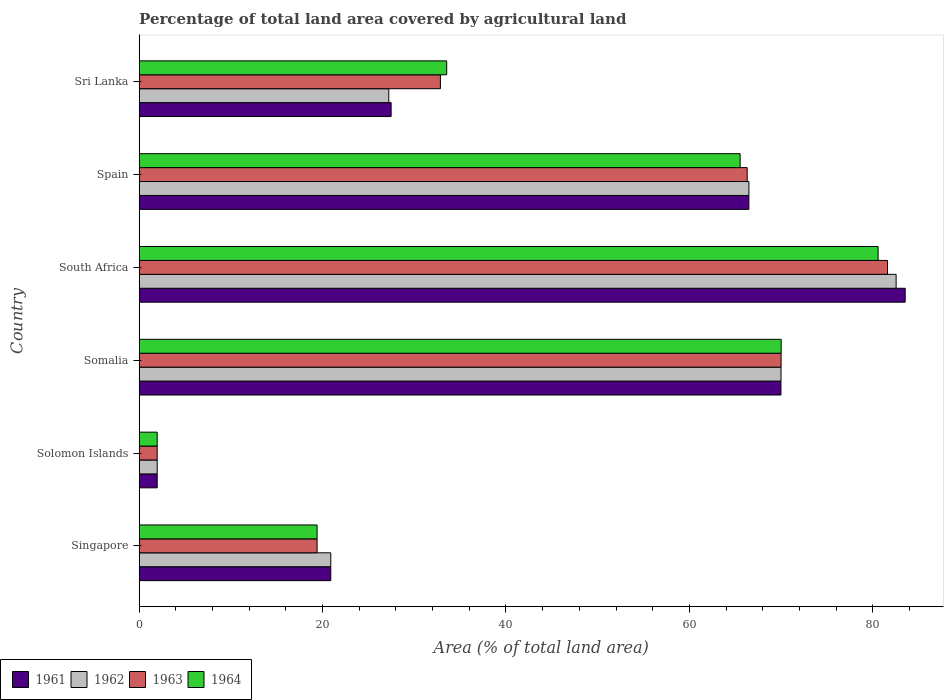How many bars are there on the 5th tick from the top?
Ensure brevity in your answer.  4. How many bars are there on the 2nd tick from the bottom?
Provide a short and direct response. 4. What is the label of the 3rd group of bars from the top?
Your response must be concise. South Africa. What is the percentage of agricultural land in 1962 in Singapore?
Give a very brief answer. 20.9. Across all countries, what is the maximum percentage of agricultural land in 1963?
Ensure brevity in your answer.  81.61. Across all countries, what is the minimum percentage of agricultural land in 1961?
Provide a succinct answer. 1.96. In which country was the percentage of agricultural land in 1963 maximum?
Provide a succinct answer. South Africa. In which country was the percentage of agricultural land in 1962 minimum?
Provide a short and direct response. Solomon Islands. What is the total percentage of agricultural land in 1964 in the graph?
Your answer should be very brief. 271.03. What is the difference between the percentage of agricultural land in 1963 in Solomon Islands and that in Spain?
Ensure brevity in your answer.  -64.34. What is the difference between the percentage of agricultural land in 1961 in Solomon Islands and the percentage of agricultural land in 1963 in Singapore?
Offer a terse response. -17.44. What is the average percentage of agricultural land in 1961 per country?
Keep it short and to the point. 45.06. What is the difference between the percentage of agricultural land in 1963 and percentage of agricultural land in 1964 in Somalia?
Give a very brief answer. -0.01. In how many countries, is the percentage of agricultural land in 1964 greater than 52 %?
Your answer should be very brief. 3. What is the ratio of the percentage of agricultural land in 1963 in Solomon Islands to that in Somalia?
Your response must be concise. 0.03. Is the percentage of agricultural land in 1962 in Somalia less than that in South Africa?
Make the answer very short. Yes. Is the difference between the percentage of agricultural land in 1963 in Singapore and Somalia greater than the difference between the percentage of agricultural land in 1964 in Singapore and Somalia?
Offer a terse response. Yes. What is the difference between the highest and the second highest percentage of agricultural land in 1964?
Your answer should be very brief. 10.57. What is the difference between the highest and the lowest percentage of agricultural land in 1962?
Ensure brevity in your answer.  80.58. Is the sum of the percentage of agricultural land in 1962 in Singapore and South Africa greater than the maximum percentage of agricultural land in 1961 across all countries?
Your answer should be very brief. Yes. What does the 1st bar from the top in Somalia represents?
Provide a short and direct response. 1964. What does the 3rd bar from the bottom in Singapore represents?
Make the answer very short. 1963. How many bars are there?
Provide a succinct answer. 24. Are all the bars in the graph horizontal?
Offer a terse response. Yes. How many countries are there in the graph?
Offer a terse response. 6. Are the values on the major ticks of X-axis written in scientific E-notation?
Your answer should be compact. No. How many legend labels are there?
Offer a very short reply. 4. What is the title of the graph?
Ensure brevity in your answer.  Percentage of total land area covered by agricultural land. What is the label or title of the X-axis?
Offer a very short reply. Area (% of total land area). What is the label or title of the Y-axis?
Keep it short and to the point. Country. What is the Area (% of total land area) in 1961 in Singapore?
Make the answer very short. 20.9. What is the Area (% of total land area) of 1962 in Singapore?
Your response must be concise. 20.9. What is the Area (% of total land area) in 1963 in Singapore?
Provide a short and direct response. 19.4. What is the Area (% of total land area) of 1964 in Singapore?
Offer a very short reply. 19.4. What is the Area (% of total land area) in 1961 in Solomon Islands?
Offer a very short reply. 1.96. What is the Area (% of total land area) of 1962 in Solomon Islands?
Your answer should be very brief. 1.96. What is the Area (% of total land area) of 1963 in Solomon Islands?
Offer a terse response. 1.96. What is the Area (% of total land area) of 1964 in Solomon Islands?
Offer a terse response. 1.96. What is the Area (% of total land area) in 1961 in Somalia?
Make the answer very short. 69.99. What is the Area (% of total land area) in 1962 in Somalia?
Keep it short and to the point. 69.99. What is the Area (% of total land area) in 1963 in Somalia?
Offer a terse response. 70. What is the Area (% of total land area) of 1964 in Somalia?
Your answer should be compact. 70.01. What is the Area (% of total land area) of 1961 in South Africa?
Provide a succinct answer. 83.53. What is the Area (% of total land area) of 1962 in South Africa?
Provide a succinct answer. 82.55. What is the Area (% of total land area) in 1963 in South Africa?
Make the answer very short. 81.61. What is the Area (% of total land area) in 1964 in South Africa?
Your response must be concise. 80.58. What is the Area (% of total land area) of 1961 in Spain?
Provide a succinct answer. 66.49. What is the Area (% of total land area) in 1962 in Spain?
Offer a terse response. 66.49. What is the Area (% of total land area) of 1963 in Spain?
Provide a short and direct response. 66.3. What is the Area (% of total land area) of 1964 in Spain?
Your answer should be compact. 65.53. What is the Area (% of total land area) in 1961 in Sri Lanka?
Offer a terse response. 27.48. What is the Area (% of total land area) in 1962 in Sri Lanka?
Offer a terse response. 27.22. What is the Area (% of total land area) of 1963 in Sri Lanka?
Your answer should be very brief. 32.85. What is the Area (% of total land area) in 1964 in Sri Lanka?
Offer a very short reply. 33.54. Across all countries, what is the maximum Area (% of total land area) of 1961?
Your response must be concise. 83.53. Across all countries, what is the maximum Area (% of total land area) of 1962?
Offer a very short reply. 82.55. Across all countries, what is the maximum Area (% of total land area) of 1963?
Keep it short and to the point. 81.61. Across all countries, what is the maximum Area (% of total land area) in 1964?
Provide a succinct answer. 80.58. Across all countries, what is the minimum Area (% of total land area) in 1961?
Offer a terse response. 1.96. Across all countries, what is the minimum Area (% of total land area) in 1962?
Your response must be concise. 1.96. Across all countries, what is the minimum Area (% of total land area) in 1963?
Give a very brief answer. 1.96. Across all countries, what is the minimum Area (% of total land area) of 1964?
Provide a succinct answer. 1.96. What is the total Area (% of total land area) in 1961 in the graph?
Provide a succinct answer. 270.35. What is the total Area (% of total land area) of 1962 in the graph?
Provide a short and direct response. 269.11. What is the total Area (% of total land area) of 1963 in the graph?
Your answer should be very brief. 272.13. What is the total Area (% of total land area) in 1964 in the graph?
Your response must be concise. 271.03. What is the difference between the Area (% of total land area) in 1961 in Singapore and that in Solomon Islands?
Your response must be concise. 18.93. What is the difference between the Area (% of total land area) in 1962 in Singapore and that in Solomon Islands?
Your response must be concise. 18.93. What is the difference between the Area (% of total land area) in 1963 in Singapore and that in Solomon Islands?
Offer a terse response. 17.44. What is the difference between the Area (% of total land area) in 1964 in Singapore and that in Solomon Islands?
Keep it short and to the point. 17.44. What is the difference between the Area (% of total land area) in 1961 in Singapore and that in Somalia?
Your answer should be very brief. -49.09. What is the difference between the Area (% of total land area) of 1962 in Singapore and that in Somalia?
Your answer should be very brief. -49.1. What is the difference between the Area (% of total land area) of 1963 in Singapore and that in Somalia?
Ensure brevity in your answer.  -50.6. What is the difference between the Area (% of total land area) in 1964 in Singapore and that in Somalia?
Your answer should be compact. -50.61. What is the difference between the Area (% of total land area) of 1961 in Singapore and that in South Africa?
Provide a succinct answer. -62.64. What is the difference between the Area (% of total land area) of 1962 in Singapore and that in South Africa?
Make the answer very short. -61.65. What is the difference between the Area (% of total land area) in 1963 in Singapore and that in South Africa?
Make the answer very short. -62.2. What is the difference between the Area (% of total land area) in 1964 in Singapore and that in South Africa?
Your answer should be very brief. -61.18. What is the difference between the Area (% of total land area) in 1961 in Singapore and that in Spain?
Make the answer very short. -45.59. What is the difference between the Area (% of total land area) in 1962 in Singapore and that in Spain?
Your answer should be very brief. -45.6. What is the difference between the Area (% of total land area) in 1963 in Singapore and that in Spain?
Give a very brief answer. -46.9. What is the difference between the Area (% of total land area) of 1964 in Singapore and that in Spain?
Your answer should be compact. -46.13. What is the difference between the Area (% of total land area) of 1961 in Singapore and that in Sri Lanka?
Your response must be concise. -6.58. What is the difference between the Area (% of total land area) in 1962 in Singapore and that in Sri Lanka?
Provide a short and direct response. -6.33. What is the difference between the Area (% of total land area) in 1963 in Singapore and that in Sri Lanka?
Keep it short and to the point. -13.45. What is the difference between the Area (% of total land area) of 1964 in Singapore and that in Sri Lanka?
Your answer should be compact. -14.13. What is the difference between the Area (% of total land area) in 1961 in Solomon Islands and that in Somalia?
Provide a succinct answer. -68.02. What is the difference between the Area (% of total land area) in 1962 in Solomon Islands and that in Somalia?
Offer a terse response. -68.03. What is the difference between the Area (% of total land area) in 1963 in Solomon Islands and that in Somalia?
Your response must be concise. -68.04. What is the difference between the Area (% of total land area) of 1964 in Solomon Islands and that in Somalia?
Provide a succinct answer. -68.04. What is the difference between the Area (% of total land area) of 1961 in Solomon Islands and that in South Africa?
Ensure brevity in your answer.  -81.57. What is the difference between the Area (% of total land area) of 1962 in Solomon Islands and that in South Africa?
Provide a succinct answer. -80.58. What is the difference between the Area (% of total land area) in 1963 in Solomon Islands and that in South Africa?
Provide a succinct answer. -79.64. What is the difference between the Area (% of total land area) in 1964 in Solomon Islands and that in South Africa?
Your response must be concise. -78.61. What is the difference between the Area (% of total land area) in 1961 in Solomon Islands and that in Spain?
Provide a succinct answer. -64.52. What is the difference between the Area (% of total land area) in 1962 in Solomon Islands and that in Spain?
Ensure brevity in your answer.  -64.53. What is the difference between the Area (% of total land area) in 1963 in Solomon Islands and that in Spain?
Offer a very short reply. -64.34. What is the difference between the Area (% of total land area) in 1964 in Solomon Islands and that in Spain?
Provide a short and direct response. -63.57. What is the difference between the Area (% of total land area) in 1961 in Solomon Islands and that in Sri Lanka?
Your answer should be compact. -25.51. What is the difference between the Area (% of total land area) in 1962 in Solomon Islands and that in Sri Lanka?
Your response must be concise. -25.26. What is the difference between the Area (% of total land area) in 1963 in Solomon Islands and that in Sri Lanka?
Your answer should be very brief. -30.88. What is the difference between the Area (% of total land area) of 1964 in Solomon Islands and that in Sri Lanka?
Provide a short and direct response. -31.57. What is the difference between the Area (% of total land area) in 1961 in Somalia and that in South Africa?
Make the answer very short. -13.55. What is the difference between the Area (% of total land area) in 1962 in Somalia and that in South Africa?
Give a very brief answer. -12.55. What is the difference between the Area (% of total land area) of 1963 in Somalia and that in South Africa?
Your answer should be very brief. -11.6. What is the difference between the Area (% of total land area) of 1964 in Somalia and that in South Africa?
Provide a succinct answer. -10.57. What is the difference between the Area (% of total land area) in 1961 in Somalia and that in Spain?
Your response must be concise. 3.5. What is the difference between the Area (% of total land area) in 1962 in Somalia and that in Spain?
Provide a short and direct response. 3.5. What is the difference between the Area (% of total land area) of 1963 in Somalia and that in Spain?
Your answer should be very brief. 3.7. What is the difference between the Area (% of total land area) of 1964 in Somalia and that in Spain?
Your answer should be very brief. 4.47. What is the difference between the Area (% of total land area) of 1961 in Somalia and that in Sri Lanka?
Ensure brevity in your answer.  42.51. What is the difference between the Area (% of total land area) of 1962 in Somalia and that in Sri Lanka?
Your response must be concise. 42.77. What is the difference between the Area (% of total land area) in 1963 in Somalia and that in Sri Lanka?
Your response must be concise. 37.15. What is the difference between the Area (% of total land area) in 1964 in Somalia and that in Sri Lanka?
Ensure brevity in your answer.  36.47. What is the difference between the Area (% of total land area) of 1961 in South Africa and that in Spain?
Offer a terse response. 17.05. What is the difference between the Area (% of total land area) of 1962 in South Africa and that in Spain?
Provide a succinct answer. 16.05. What is the difference between the Area (% of total land area) in 1963 in South Africa and that in Spain?
Offer a very short reply. 15.3. What is the difference between the Area (% of total land area) of 1964 in South Africa and that in Spain?
Your response must be concise. 15.04. What is the difference between the Area (% of total land area) of 1961 in South Africa and that in Sri Lanka?
Provide a succinct answer. 56.06. What is the difference between the Area (% of total land area) of 1962 in South Africa and that in Sri Lanka?
Provide a short and direct response. 55.32. What is the difference between the Area (% of total land area) in 1963 in South Africa and that in Sri Lanka?
Offer a very short reply. 48.76. What is the difference between the Area (% of total land area) in 1964 in South Africa and that in Sri Lanka?
Ensure brevity in your answer.  47.04. What is the difference between the Area (% of total land area) in 1961 in Spain and that in Sri Lanka?
Provide a succinct answer. 39.01. What is the difference between the Area (% of total land area) in 1962 in Spain and that in Sri Lanka?
Make the answer very short. 39.27. What is the difference between the Area (% of total land area) of 1963 in Spain and that in Sri Lanka?
Your answer should be compact. 33.45. What is the difference between the Area (% of total land area) in 1964 in Spain and that in Sri Lanka?
Offer a terse response. 32. What is the difference between the Area (% of total land area) of 1961 in Singapore and the Area (% of total land area) of 1962 in Solomon Islands?
Ensure brevity in your answer.  18.93. What is the difference between the Area (% of total land area) in 1961 in Singapore and the Area (% of total land area) in 1963 in Solomon Islands?
Ensure brevity in your answer.  18.93. What is the difference between the Area (% of total land area) of 1961 in Singapore and the Area (% of total land area) of 1964 in Solomon Islands?
Your answer should be very brief. 18.93. What is the difference between the Area (% of total land area) of 1962 in Singapore and the Area (% of total land area) of 1963 in Solomon Islands?
Your answer should be compact. 18.93. What is the difference between the Area (% of total land area) of 1962 in Singapore and the Area (% of total land area) of 1964 in Solomon Islands?
Your response must be concise. 18.93. What is the difference between the Area (% of total land area) of 1963 in Singapore and the Area (% of total land area) of 1964 in Solomon Islands?
Provide a succinct answer. 17.44. What is the difference between the Area (% of total land area) in 1961 in Singapore and the Area (% of total land area) in 1962 in Somalia?
Your response must be concise. -49.1. What is the difference between the Area (% of total land area) in 1961 in Singapore and the Area (% of total land area) in 1963 in Somalia?
Give a very brief answer. -49.11. What is the difference between the Area (% of total land area) of 1961 in Singapore and the Area (% of total land area) of 1964 in Somalia?
Your answer should be very brief. -49.11. What is the difference between the Area (% of total land area) in 1962 in Singapore and the Area (% of total land area) in 1963 in Somalia?
Offer a very short reply. -49.11. What is the difference between the Area (% of total land area) of 1962 in Singapore and the Area (% of total land area) of 1964 in Somalia?
Your answer should be very brief. -49.11. What is the difference between the Area (% of total land area) of 1963 in Singapore and the Area (% of total land area) of 1964 in Somalia?
Your answer should be compact. -50.61. What is the difference between the Area (% of total land area) in 1961 in Singapore and the Area (% of total land area) in 1962 in South Africa?
Keep it short and to the point. -61.65. What is the difference between the Area (% of total land area) in 1961 in Singapore and the Area (% of total land area) in 1963 in South Africa?
Provide a succinct answer. -60.71. What is the difference between the Area (% of total land area) of 1961 in Singapore and the Area (% of total land area) of 1964 in South Africa?
Your answer should be compact. -59.68. What is the difference between the Area (% of total land area) of 1962 in Singapore and the Area (% of total land area) of 1963 in South Africa?
Your answer should be very brief. -60.71. What is the difference between the Area (% of total land area) in 1962 in Singapore and the Area (% of total land area) in 1964 in South Africa?
Offer a very short reply. -59.68. What is the difference between the Area (% of total land area) of 1963 in Singapore and the Area (% of total land area) of 1964 in South Africa?
Provide a short and direct response. -61.18. What is the difference between the Area (% of total land area) of 1961 in Singapore and the Area (% of total land area) of 1962 in Spain?
Ensure brevity in your answer.  -45.6. What is the difference between the Area (% of total land area) of 1961 in Singapore and the Area (% of total land area) of 1963 in Spain?
Offer a very short reply. -45.41. What is the difference between the Area (% of total land area) of 1961 in Singapore and the Area (% of total land area) of 1964 in Spain?
Offer a very short reply. -44.64. What is the difference between the Area (% of total land area) of 1962 in Singapore and the Area (% of total land area) of 1963 in Spain?
Your response must be concise. -45.41. What is the difference between the Area (% of total land area) of 1962 in Singapore and the Area (% of total land area) of 1964 in Spain?
Offer a terse response. -44.64. What is the difference between the Area (% of total land area) of 1963 in Singapore and the Area (% of total land area) of 1964 in Spain?
Offer a terse response. -46.13. What is the difference between the Area (% of total land area) of 1961 in Singapore and the Area (% of total land area) of 1962 in Sri Lanka?
Keep it short and to the point. -6.33. What is the difference between the Area (% of total land area) in 1961 in Singapore and the Area (% of total land area) in 1963 in Sri Lanka?
Offer a very short reply. -11.95. What is the difference between the Area (% of total land area) in 1961 in Singapore and the Area (% of total land area) in 1964 in Sri Lanka?
Ensure brevity in your answer.  -12.64. What is the difference between the Area (% of total land area) in 1962 in Singapore and the Area (% of total land area) in 1963 in Sri Lanka?
Make the answer very short. -11.95. What is the difference between the Area (% of total land area) of 1962 in Singapore and the Area (% of total land area) of 1964 in Sri Lanka?
Provide a succinct answer. -12.64. What is the difference between the Area (% of total land area) in 1963 in Singapore and the Area (% of total land area) in 1964 in Sri Lanka?
Offer a very short reply. -14.13. What is the difference between the Area (% of total land area) of 1961 in Solomon Islands and the Area (% of total land area) of 1962 in Somalia?
Make the answer very short. -68.03. What is the difference between the Area (% of total land area) in 1961 in Solomon Islands and the Area (% of total land area) in 1963 in Somalia?
Offer a very short reply. -68.04. What is the difference between the Area (% of total land area) of 1961 in Solomon Islands and the Area (% of total land area) of 1964 in Somalia?
Ensure brevity in your answer.  -68.04. What is the difference between the Area (% of total land area) in 1962 in Solomon Islands and the Area (% of total land area) in 1963 in Somalia?
Your answer should be very brief. -68.04. What is the difference between the Area (% of total land area) in 1962 in Solomon Islands and the Area (% of total land area) in 1964 in Somalia?
Provide a short and direct response. -68.04. What is the difference between the Area (% of total land area) in 1963 in Solomon Islands and the Area (% of total land area) in 1964 in Somalia?
Offer a terse response. -68.04. What is the difference between the Area (% of total land area) of 1961 in Solomon Islands and the Area (% of total land area) of 1962 in South Africa?
Your answer should be compact. -80.58. What is the difference between the Area (% of total land area) in 1961 in Solomon Islands and the Area (% of total land area) in 1963 in South Africa?
Make the answer very short. -79.64. What is the difference between the Area (% of total land area) in 1961 in Solomon Islands and the Area (% of total land area) in 1964 in South Africa?
Your answer should be very brief. -78.61. What is the difference between the Area (% of total land area) of 1962 in Solomon Islands and the Area (% of total land area) of 1963 in South Africa?
Make the answer very short. -79.64. What is the difference between the Area (% of total land area) in 1962 in Solomon Islands and the Area (% of total land area) in 1964 in South Africa?
Keep it short and to the point. -78.61. What is the difference between the Area (% of total land area) of 1963 in Solomon Islands and the Area (% of total land area) of 1964 in South Africa?
Your answer should be compact. -78.61. What is the difference between the Area (% of total land area) of 1961 in Solomon Islands and the Area (% of total land area) of 1962 in Spain?
Provide a succinct answer. -64.53. What is the difference between the Area (% of total land area) in 1961 in Solomon Islands and the Area (% of total land area) in 1963 in Spain?
Provide a succinct answer. -64.34. What is the difference between the Area (% of total land area) in 1961 in Solomon Islands and the Area (% of total land area) in 1964 in Spain?
Ensure brevity in your answer.  -63.57. What is the difference between the Area (% of total land area) of 1962 in Solomon Islands and the Area (% of total land area) of 1963 in Spain?
Your answer should be compact. -64.34. What is the difference between the Area (% of total land area) of 1962 in Solomon Islands and the Area (% of total land area) of 1964 in Spain?
Your response must be concise. -63.57. What is the difference between the Area (% of total land area) of 1963 in Solomon Islands and the Area (% of total land area) of 1964 in Spain?
Ensure brevity in your answer.  -63.57. What is the difference between the Area (% of total land area) in 1961 in Solomon Islands and the Area (% of total land area) in 1962 in Sri Lanka?
Provide a succinct answer. -25.26. What is the difference between the Area (% of total land area) of 1961 in Solomon Islands and the Area (% of total land area) of 1963 in Sri Lanka?
Provide a short and direct response. -30.88. What is the difference between the Area (% of total land area) in 1961 in Solomon Islands and the Area (% of total land area) in 1964 in Sri Lanka?
Keep it short and to the point. -31.57. What is the difference between the Area (% of total land area) in 1962 in Solomon Islands and the Area (% of total land area) in 1963 in Sri Lanka?
Provide a short and direct response. -30.88. What is the difference between the Area (% of total land area) of 1962 in Solomon Islands and the Area (% of total land area) of 1964 in Sri Lanka?
Ensure brevity in your answer.  -31.57. What is the difference between the Area (% of total land area) in 1963 in Solomon Islands and the Area (% of total land area) in 1964 in Sri Lanka?
Your answer should be very brief. -31.57. What is the difference between the Area (% of total land area) of 1961 in Somalia and the Area (% of total land area) of 1962 in South Africa?
Give a very brief answer. -12.56. What is the difference between the Area (% of total land area) in 1961 in Somalia and the Area (% of total land area) in 1963 in South Africa?
Your response must be concise. -11.62. What is the difference between the Area (% of total land area) of 1961 in Somalia and the Area (% of total land area) of 1964 in South Africa?
Make the answer very short. -10.59. What is the difference between the Area (% of total land area) of 1962 in Somalia and the Area (% of total land area) of 1963 in South Africa?
Provide a short and direct response. -11.61. What is the difference between the Area (% of total land area) in 1962 in Somalia and the Area (% of total land area) in 1964 in South Africa?
Offer a very short reply. -10.59. What is the difference between the Area (% of total land area) of 1963 in Somalia and the Area (% of total land area) of 1964 in South Africa?
Make the answer very short. -10.58. What is the difference between the Area (% of total land area) in 1961 in Somalia and the Area (% of total land area) in 1962 in Spain?
Offer a terse response. 3.49. What is the difference between the Area (% of total land area) of 1961 in Somalia and the Area (% of total land area) of 1963 in Spain?
Your answer should be very brief. 3.68. What is the difference between the Area (% of total land area) of 1961 in Somalia and the Area (% of total land area) of 1964 in Spain?
Your answer should be very brief. 4.45. What is the difference between the Area (% of total land area) in 1962 in Somalia and the Area (% of total land area) in 1963 in Spain?
Provide a succinct answer. 3.69. What is the difference between the Area (% of total land area) of 1962 in Somalia and the Area (% of total land area) of 1964 in Spain?
Your response must be concise. 4.46. What is the difference between the Area (% of total land area) in 1963 in Somalia and the Area (% of total land area) in 1964 in Spain?
Keep it short and to the point. 4.47. What is the difference between the Area (% of total land area) of 1961 in Somalia and the Area (% of total land area) of 1962 in Sri Lanka?
Your response must be concise. 42.77. What is the difference between the Area (% of total land area) of 1961 in Somalia and the Area (% of total land area) of 1963 in Sri Lanka?
Give a very brief answer. 37.14. What is the difference between the Area (% of total land area) in 1961 in Somalia and the Area (% of total land area) in 1964 in Sri Lanka?
Give a very brief answer. 36.45. What is the difference between the Area (% of total land area) of 1962 in Somalia and the Area (% of total land area) of 1963 in Sri Lanka?
Offer a terse response. 37.14. What is the difference between the Area (% of total land area) in 1962 in Somalia and the Area (% of total land area) in 1964 in Sri Lanka?
Give a very brief answer. 36.46. What is the difference between the Area (% of total land area) in 1963 in Somalia and the Area (% of total land area) in 1964 in Sri Lanka?
Ensure brevity in your answer.  36.47. What is the difference between the Area (% of total land area) in 1961 in South Africa and the Area (% of total land area) in 1962 in Spain?
Your response must be concise. 17.04. What is the difference between the Area (% of total land area) in 1961 in South Africa and the Area (% of total land area) in 1963 in Spain?
Your response must be concise. 17.23. What is the difference between the Area (% of total land area) of 1961 in South Africa and the Area (% of total land area) of 1964 in Spain?
Provide a short and direct response. 18. What is the difference between the Area (% of total land area) in 1962 in South Africa and the Area (% of total land area) in 1963 in Spain?
Your answer should be very brief. 16.24. What is the difference between the Area (% of total land area) of 1962 in South Africa and the Area (% of total land area) of 1964 in Spain?
Your response must be concise. 17.01. What is the difference between the Area (% of total land area) in 1963 in South Africa and the Area (% of total land area) in 1964 in Spain?
Provide a succinct answer. 16.07. What is the difference between the Area (% of total land area) in 1961 in South Africa and the Area (% of total land area) in 1962 in Sri Lanka?
Ensure brevity in your answer.  56.31. What is the difference between the Area (% of total land area) of 1961 in South Africa and the Area (% of total land area) of 1963 in Sri Lanka?
Provide a succinct answer. 50.69. What is the difference between the Area (% of total land area) in 1961 in South Africa and the Area (% of total land area) in 1964 in Sri Lanka?
Make the answer very short. 50. What is the difference between the Area (% of total land area) of 1962 in South Africa and the Area (% of total land area) of 1963 in Sri Lanka?
Keep it short and to the point. 49.7. What is the difference between the Area (% of total land area) in 1962 in South Africa and the Area (% of total land area) in 1964 in Sri Lanka?
Offer a very short reply. 49.01. What is the difference between the Area (% of total land area) of 1963 in South Africa and the Area (% of total land area) of 1964 in Sri Lanka?
Provide a succinct answer. 48.07. What is the difference between the Area (% of total land area) of 1961 in Spain and the Area (% of total land area) of 1962 in Sri Lanka?
Your answer should be compact. 39.27. What is the difference between the Area (% of total land area) in 1961 in Spain and the Area (% of total land area) in 1963 in Sri Lanka?
Your answer should be compact. 33.64. What is the difference between the Area (% of total land area) in 1961 in Spain and the Area (% of total land area) in 1964 in Sri Lanka?
Provide a succinct answer. 32.95. What is the difference between the Area (% of total land area) of 1962 in Spain and the Area (% of total land area) of 1963 in Sri Lanka?
Your answer should be compact. 33.64. What is the difference between the Area (% of total land area) of 1962 in Spain and the Area (% of total land area) of 1964 in Sri Lanka?
Provide a short and direct response. 32.96. What is the difference between the Area (% of total land area) of 1963 in Spain and the Area (% of total land area) of 1964 in Sri Lanka?
Offer a terse response. 32.77. What is the average Area (% of total land area) of 1961 per country?
Provide a succinct answer. 45.06. What is the average Area (% of total land area) in 1962 per country?
Provide a succinct answer. 44.85. What is the average Area (% of total land area) in 1963 per country?
Offer a very short reply. 45.35. What is the average Area (% of total land area) of 1964 per country?
Ensure brevity in your answer.  45.17. What is the difference between the Area (% of total land area) in 1961 and Area (% of total land area) in 1962 in Singapore?
Offer a very short reply. 0. What is the difference between the Area (% of total land area) of 1961 and Area (% of total land area) of 1963 in Singapore?
Make the answer very short. 1.49. What is the difference between the Area (% of total land area) of 1961 and Area (% of total land area) of 1964 in Singapore?
Your answer should be compact. 1.49. What is the difference between the Area (% of total land area) of 1962 and Area (% of total land area) of 1963 in Singapore?
Provide a short and direct response. 1.49. What is the difference between the Area (% of total land area) of 1962 and Area (% of total land area) of 1964 in Singapore?
Your answer should be compact. 1.49. What is the difference between the Area (% of total land area) in 1963 and Area (% of total land area) in 1964 in Singapore?
Your response must be concise. 0. What is the difference between the Area (% of total land area) of 1961 and Area (% of total land area) of 1963 in Solomon Islands?
Your answer should be very brief. 0. What is the difference between the Area (% of total land area) of 1962 and Area (% of total land area) of 1964 in Solomon Islands?
Your answer should be very brief. 0. What is the difference between the Area (% of total land area) of 1963 and Area (% of total land area) of 1964 in Solomon Islands?
Keep it short and to the point. 0. What is the difference between the Area (% of total land area) in 1961 and Area (% of total land area) in 1962 in Somalia?
Make the answer very short. -0.01. What is the difference between the Area (% of total land area) in 1961 and Area (% of total land area) in 1963 in Somalia?
Your answer should be compact. -0.02. What is the difference between the Area (% of total land area) in 1961 and Area (% of total land area) in 1964 in Somalia?
Your answer should be very brief. -0.02. What is the difference between the Area (% of total land area) of 1962 and Area (% of total land area) of 1963 in Somalia?
Ensure brevity in your answer.  -0.01. What is the difference between the Area (% of total land area) of 1962 and Area (% of total land area) of 1964 in Somalia?
Offer a very short reply. -0.02. What is the difference between the Area (% of total land area) of 1963 and Area (% of total land area) of 1964 in Somalia?
Ensure brevity in your answer.  -0.01. What is the difference between the Area (% of total land area) in 1961 and Area (% of total land area) in 1963 in South Africa?
Your response must be concise. 1.93. What is the difference between the Area (% of total land area) in 1961 and Area (% of total land area) in 1964 in South Africa?
Your answer should be very brief. 2.96. What is the difference between the Area (% of total land area) of 1962 and Area (% of total land area) of 1963 in South Africa?
Keep it short and to the point. 0.94. What is the difference between the Area (% of total land area) in 1962 and Area (% of total land area) in 1964 in South Africa?
Your answer should be very brief. 1.97. What is the difference between the Area (% of total land area) of 1963 and Area (% of total land area) of 1964 in South Africa?
Make the answer very short. 1.03. What is the difference between the Area (% of total land area) in 1961 and Area (% of total land area) in 1962 in Spain?
Your response must be concise. -0. What is the difference between the Area (% of total land area) of 1961 and Area (% of total land area) of 1963 in Spain?
Your response must be concise. 0.19. What is the difference between the Area (% of total land area) in 1961 and Area (% of total land area) in 1964 in Spain?
Your answer should be very brief. 0.95. What is the difference between the Area (% of total land area) in 1962 and Area (% of total land area) in 1963 in Spain?
Provide a succinct answer. 0.19. What is the difference between the Area (% of total land area) of 1962 and Area (% of total land area) of 1964 in Spain?
Your answer should be compact. 0.96. What is the difference between the Area (% of total land area) in 1963 and Area (% of total land area) in 1964 in Spain?
Ensure brevity in your answer.  0.77. What is the difference between the Area (% of total land area) in 1961 and Area (% of total land area) in 1962 in Sri Lanka?
Offer a terse response. 0.26. What is the difference between the Area (% of total land area) of 1961 and Area (% of total land area) of 1963 in Sri Lanka?
Offer a terse response. -5.37. What is the difference between the Area (% of total land area) in 1961 and Area (% of total land area) in 1964 in Sri Lanka?
Offer a terse response. -6.06. What is the difference between the Area (% of total land area) in 1962 and Area (% of total land area) in 1963 in Sri Lanka?
Your answer should be compact. -5.63. What is the difference between the Area (% of total land area) in 1962 and Area (% of total land area) in 1964 in Sri Lanka?
Make the answer very short. -6.31. What is the difference between the Area (% of total land area) of 1963 and Area (% of total land area) of 1964 in Sri Lanka?
Provide a short and direct response. -0.69. What is the ratio of the Area (% of total land area) of 1961 in Singapore to that in Solomon Islands?
Make the answer very short. 10.63. What is the ratio of the Area (% of total land area) of 1962 in Singapore to that in Solomon Islands?
Ensure brevity in your answer.  10.63. What is the ratio of the Area (% of total land area) of 1963 in Singapore to that in Solomon Islands?
Your response must be concise. 9.87. What is the ratio of the Area (% of total land area) in 1964 in Singapore to that in Solomon Islands?
Make the answer very short. 9.87. What is the ratio of the Area (% of total land area) in 1961 in Singapore to that in Somalia?
Offer a very short reply. 0.3. What is the ratio of the Area (% of total land area) of 1962 in Singapore to that in Somalia?
Your answer should be compact. 0.3. What is the ratio of the Area (% of total land area) of 1963 in Singapore to that in Somalia?
Your answer should be very brief. 0.28. What is the ratio of the Area (% of total land area) of 1964 in Singapore to that in Somalia?
Your response must be concise. 0.28. What is the ratio of the Area (% of total land area) of 1961 in Singapore to that in South Africa?
Your response must be concise. 0.25. What is the ratio of the Area (% of total land area) of 1962 in Singapore to that in South Africa?
Make the answer very short. 0.25. What is the ratio of the Area (% of total land area) in 1963 in Singapore to that in South Africa?
Your answer should be compact. 0.24. What is the ratio of the Area (% of total land area) of 1964 in Singapore to that in South Africa?
Your answer should be compact. 0.24. What is the ratio of the Area (% of total land area) of 1961 in Singapore to that in Spain?
Keep it short and to the point. 0.31. What is the ratio of the Area (% of total land area) of 1962 in Singapore to that in Spain?
Keep it short and to the point. 0.31. What is the ratio of the Area (% of total land area) in 1963 in Singapore to that in Spain?
Keep it short and to the point. 0.29. What is the ratio of the Area (% of total land area) of 1964 in Singapore to that in Spain?
Provide a succinct answer. 0.3. What is the ratio of the Area (% of total land area) of 1961 in Singapore to that in Sri Lanka?
Your response must be concise. 0.76. What is the ratio of the Area (% of total land area) of 1962 in Singapore to that in Sri Lanka?
Offer a terse response. 0.77. What is the ratio of the Area (% of total land area) of 1963 in Singapore to that in Sri Lanka?
Offer a very short reply. 0.59. What is the ratio of the Area (% of total land area) of 1964 in Singapore to that in Sri Lanka?
Offer a terse response. 0.58. What is the ratio of the Area (% of total land area) in 1961 in Solomon Islands to that in Somalia?
Offer a terse response. 0.03. What is the ratio of the Area (% of total land area) of 1962 in Solomon Islands to that in Somalia?
Provide a succinct answer. 0.03. What is the ratio of the Area (% of total land area) in 1963 in Solomon Islands to that in Somalia?
Your answer should be compact. 0.03. What is the ratio of the Area (% of total land area) in 1964 in Solomon Islands to that in Somalia?
Provide a succinct answer. 0.03. What is the ratio of the Area (% of total land area) of 1961 in Solomon Islands to that in South Africa?
Your answer should be very brief. 0.02. What is the ratio of the Area (% of total land area) of 1962 in Solomon Islands to that in South Africa?
Offer a terse response. 0.02. What is the ratio of the Area (% of total land area) of 1963 in Solomon Islands to that in South Africa?
Your answer should be compact. 0.02. What is the ratio of the Area (% of total land area) in 1964 in Solomon Islands to that in South Africa?
Your response must be concise. 0.02. What is the ratio of the Area (% of total land area) in 1961 in Solomon Islands to that in Spain?
Your answer should be compact. 0.03. What is the ratio of the Area (% of total land area) of 1962 in Solomon Islands to that in Spain?
Your response must be concise. 0.03. What is the ratio of the Area (% of total land area) in 1963 in Solomon Islands to that in Spain?
Give a very brief answer. 0.03. What is the ratio of the Area (% of total land area) of 1964 in Solomon Islands to that in Spain?
Provide a succinct answer. 0.03. What is the ratio of the Area (% of total land area) in 1961 in Solomon Islands to that in Sri Lanka?
Offer a very short reply. 0.07. What is the ratio of the Area (% of total land area) in 1962 in Solomon Islands to that in Sri Lanka?
Make the answer very short. 0.07. What is the ratio of the Area (% of total land area) of 1963 in Solomon Islands to that in Sri Lanka?
Offer a very short reply. 0.06. What is the ratio of the Area (% of total land area) of 1964 in Solomon Islands to that in Sri Lanka?
Keep it short and to the point. 0.06. What is the ratio of the Area (% of total land area) of 1961 in Somalia to that in South Africa?
Provide a short and direct response. 0.84. What is the ratio of the Area (% of total land area) of 1962 in Somalia to that in South Africa?
Offer a very short reply. 0.85. What is the ratio of the Area (% of total land area) of 1963 in Somalia to that in South Africa?
Provide a short and direct response. 0.86. What is the ratio of the Area (% of total land area) in 1964 in Somalia to that in South Africa?
Keep it short and to the point. 0.87. What is the ratio of the Area (% of total land area) of 1961 in Somalia to that in Spain?
Your answer should be compact. 1.05. What is the ratio of the Area (% of total land area) in 1962 in Somalia to that in Spain?
Your response must be concise. 1.05. What is the ratio of the Area (% of total land area) in 1963 in Somalia to that in Spain?
Keep it short and to the point. 1.06. What is the ratio of the Area (% of total land area) in 1964 in Somalia to that in Spain?
Provide a succinct answer. 1.07. What is the ratio of the Area (% of total land area) of 1961 in Somalia to that in Sri Lanka?
Provide a short and direct response. 2.55. What is the ratio of the Area (% of total land area) in 1962 in Somalia to that in Sri Lanka?
Your answer should be compact. 2.57. What is the ratio of the Area (% of total land area) in 1963 in Somalia to that in Sri Lanka?
Ensure brevity in your answer.  2.13. What is the ratio of the Area (% of total land area) of 1964 in Somalia to that in Sri Lanka?
Your answer should be very brief. 2.09. What is the ratio of the Area (% of total land area) of 1961 in South Africa to that in Spain?
Ensure brevity in your answer.  1.26. What is the ratio of the Area (% of total land area) of 1962 in South Africa to that in Spain?
Offer a terse response. 1.24. What is the ratio of the Area (% of total land area) of 1963 in South Africa to that in Spain?
Provide a short and direct response. 1.23. What is the ratio of the Area (% of total land area) of 1964 in South Africa to that in Spain?
Provide a short and direct response. 1.23. What is the ratio of the Area (% of total land area) of 1961 in South Africa to that in Sri Lanka?
Make the answer very short. 3.04. What is the ratio of the Area (% of total land area) in 1962 in South Africa to that in Sri Lanka?
Give a very brief answer. 3.03. What is the ratio of the Area (% of total land area) in 1963 in South Africa to that in Sri Lanka?
Ensure brevity in your answer.  2.48. What is the ratio of the Area (% of total land area) of 1964 in South Africa to that in Sri Lanka?
Make the answer very short. 2.4. What is the ratio of the Area (% of total land area) of 1961 in Spain to that in Sri Lanka?
Provide a short and direct response. 2.42. What is the ratio of the Area (% of total land area) in 1962 in Spain to that in Sri Lanka?
Offer a terse response. 2.44. What is the ratio of the Area (% of total land area) of 1963 in Spain to that in Sri Lanka?
Ensure brevity in your answer.  2.02. What is the ratio of the Area (% of total land area) in 1964 in Spain to that in Sri Lanka?
Provide a short and direct response. 1.95. What is the difference between the highest and the second highest Area (% of total land area) in 1961?
Make the answer very short. 13.55. What is the difference between the highest and the second highest Area (% of total land area) in 1962?
Give a very brief answer. 12.55. What is the difference between the highest and the second highest Area (% of total land area) in 1963?
Your answer should be very brief. 11.6. What is the difference between the highest and the second highest Area (% of total land area) of 1964?
Offer a terse response. 10.57. What is the difference between the highest and the lowest Area (% of total land area) in 1961?
Give a very brief answer. 81.57. What is the difference between the highest and the lowest Area (% of total land area) of 1962?
Offer a terse response. 80.58. What is the difference between the highest and the lowest Area (% of total land area) in 1963?
Ensure brevity in your answer.  79.64. What is the difference between the highest and the lowest Area (% of total land area) in 1964?
Offer a terse response. 78.61. 